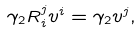Convert formula to latex. <formula><loc_0><loc_0><loc_500><loc_500>\gamma _ { 2 } R ^ { j } _ { i } v ^ { i } = \gamma _ { 2 } v ^ { j } ,</formula> 